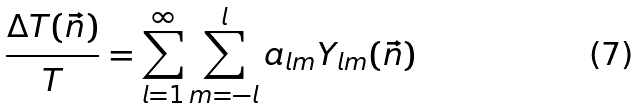<formula> <loc_0><loc_0><loc_500><loc_500>\frac { \Delta T ( \vec { n } ) } { T } = \sum _ { l = 1 } ^ { \infty } \sum _ { m = - l } ^ { l } a _ { l m } Y _ { l m } ( \vec { n } )</formula> 